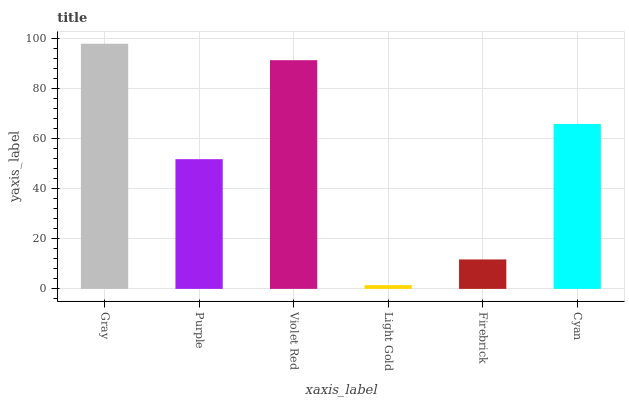Is Purple the minimum?
Answer yes or no. No. Is Purple the maximum?
Answer yes or no. No. Is Gray greater than Purple?
Answer yes or no. Yes. Is Purple less than Gray?
Answer yes or no. Yes. Is Purple greater than Gray?
Answer yes or no. No. Is Gray less than Purple?
Answer yes or no. No. Is Cyan the high median?
Answer yes or no. Yes. Is Purple the low median?
Answer yes or no. Yes. Is Light Gold the high median?
Answer yes or no. No. Is Cyan the low median?
Answer yes or no. No. 